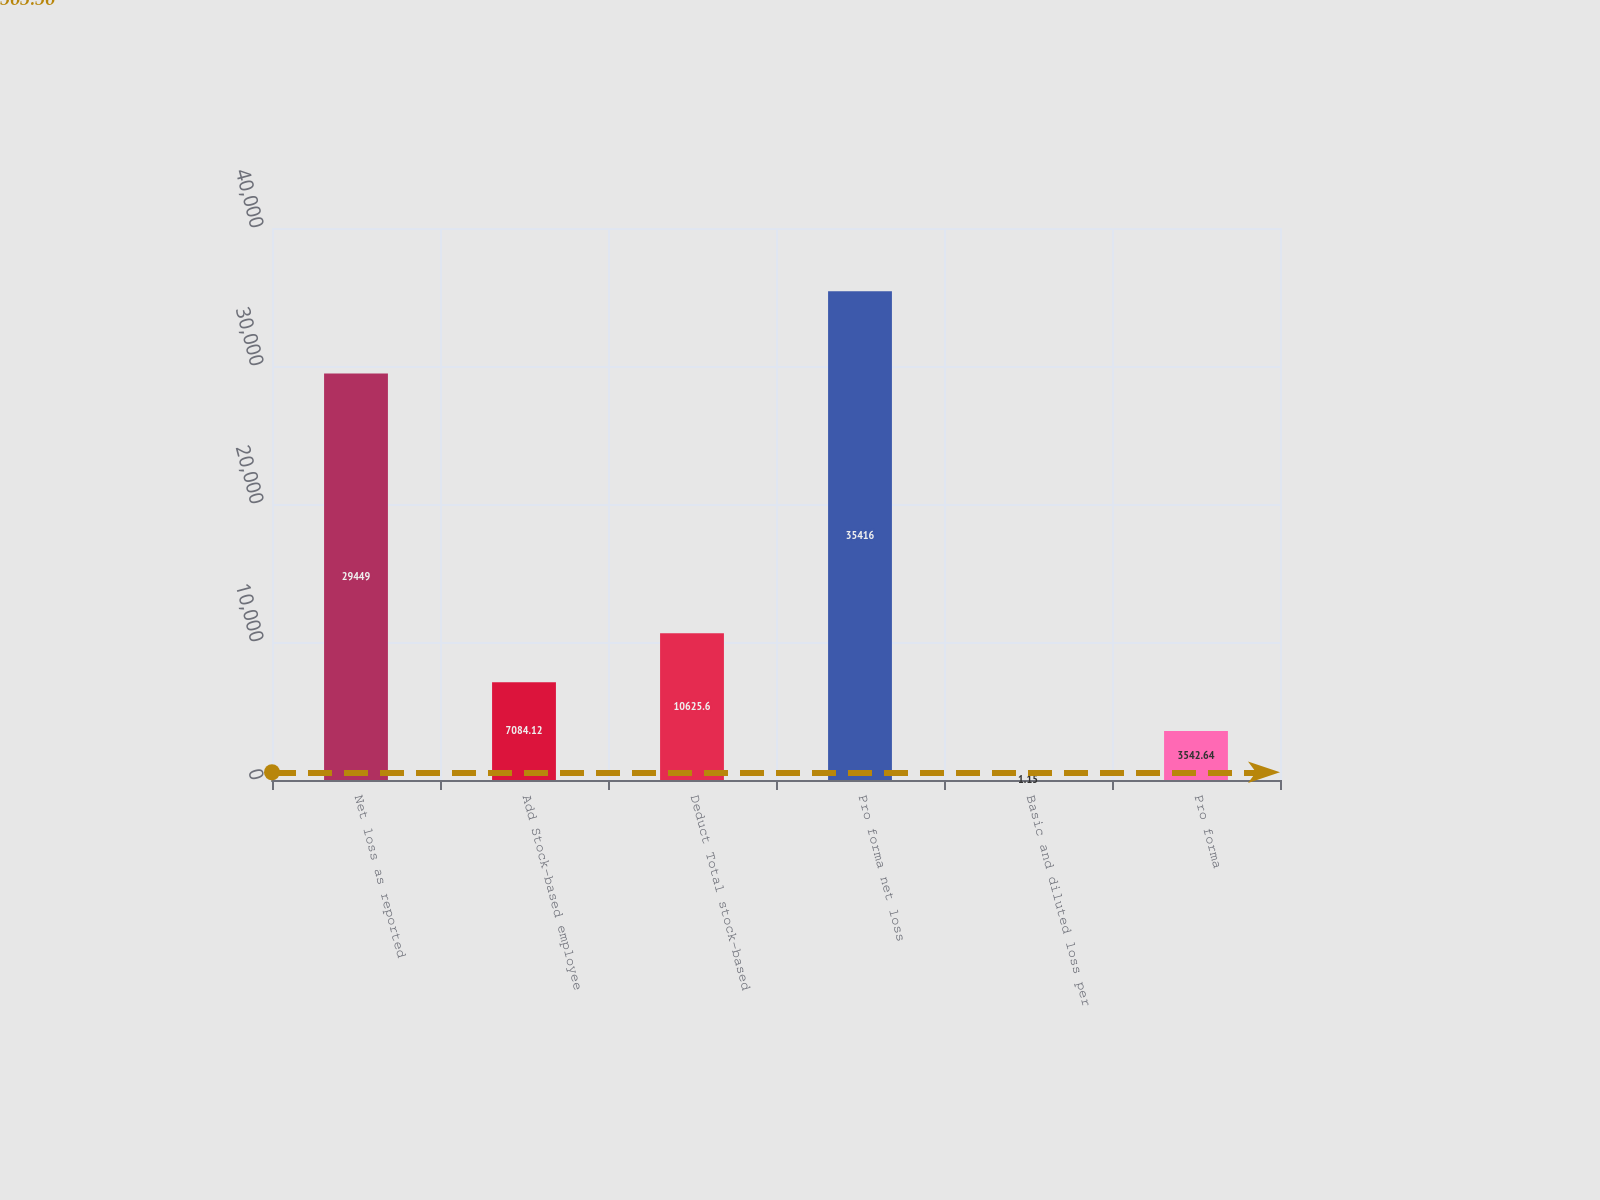Convert chart. <chart><loc_0><loc_0><loc_500><loc_500><bar_chart><fcel>Net loss as reported<fcel>Add Stock-based employee<fcel>Deduct Total stock-based<fcel>Pro forma net loss<fcel>Basic and diluted loss per<fcel>Pro forma<nl><fcel>29449<fcel>7084.12<fcel>10625.6<fcel>35416<fcel>1.15<fcel>3542.64<nl></chart> 